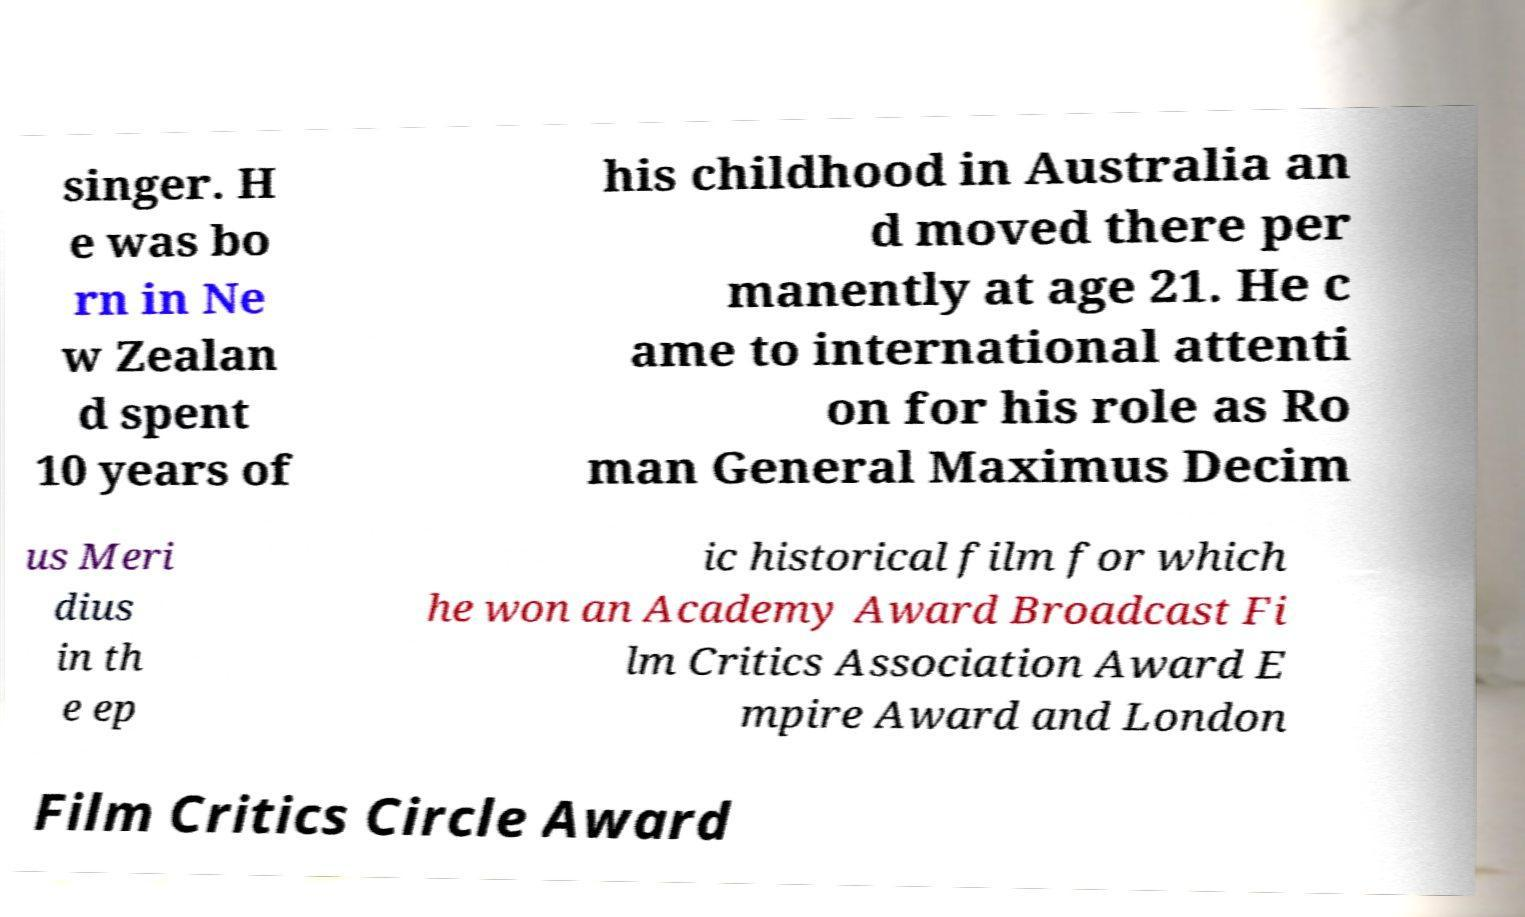There's text embedded in this image that I need extracted. Can you transcribe it verbatim? singer. H e was bo rn in Ne w Zealan d spent 10 years of his childhood in Australia an d moved there per manently at age 21. He c ame to international attenti on for his role as Ro man General Maximus Decim us Meri dius in th e ep ic historical film for which he won an Academy Award Broadcast Fi lm Critics Association Award E mpire Award and London Film Critics Circle Award 